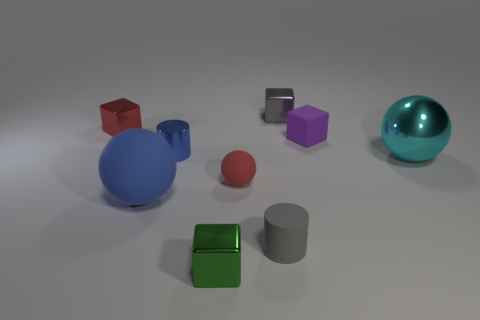Subtract all small gray cubes. How many cubes are left? 3 Subtract 1 balls. How many balls are left? 2 Add 1 tiny rubber cylinders. How many objects exist? 10 Subtract all gray blocks. How many blocks are left? 3 Subtract all cylinders. How many objects are left? 7 Subtract all red balls. Subtract all green blocks. How many balls are left? 2 Subtract all metallic cylinders. Subtract all large blue matte objects. How many objects are left? 7 Add 3 blue metallic cylinders. How many blue metallic cylinders are left? 4 Add 6 small brown metallic blocks. How many small brown metallic blocks exist? 6 Subtract 0 cyan cylinders. How many objects are left? 9 